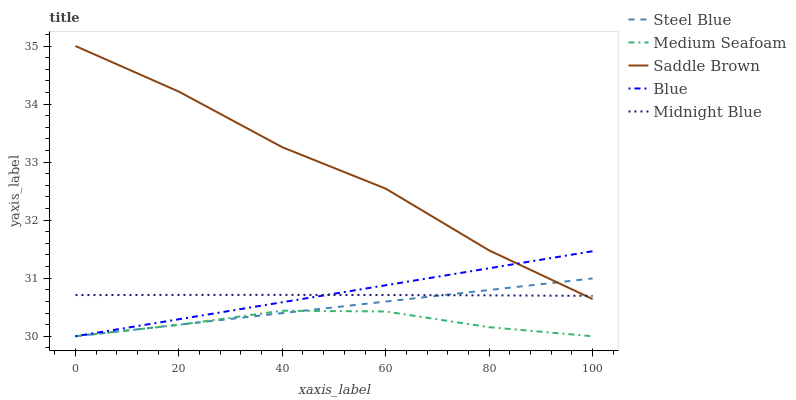Does Medium Seafoam have the minimum area under the curve?
Answer yes or no. Yes. Does Saddle Brown have the maximum area under the curve?
Answer yes or no. Yes. Does Blue have the minimum area under the curve?
Answer yes or no. No. Does Blue have the maximum area under the curve?
Answer yes or no. No. Is Blue the smoothest?
Answer yes or no. Yes. Is Saddle Brown the roughest?
Answer yes or no. Yes. Is Midnight Blue the smoothest?
Answer yes or no. No. Is Midnight Blue the roughest?
Answer yes or no. No. Does Blue have the lowest value?
Answer yes or no. Yes. Does Midnight Blue have the lowest value?
Answer yes or no. No. Does Saddle Brown have the highest value?
Answer yes or no. Yes. Does Blue have the highest value?
Answer yes or no. No. Is Medium Seafoam less than Saddle Brown?
Answer yes or no. Yes. Is Midnight Blue greater than Medium Seafoam?
Answer yes or no. Yes. Does Steel Blue intersect Blue?
Answer yes or no. Yes. Is Steel Blue less than Blue?
Answer yes or no. No. Is Steel Blue greater than Blue?
Answer yes or no. No. Does Medium Seafoam intersect Saddle Brown?
Answer yes or no. No. 